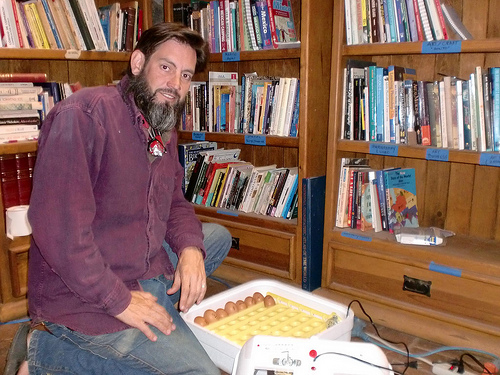<image>
Is the book on the shelf? Yes. Looking at the image, I can see the book is positioned on top of the shelf, with the shelf providing support. Is there a book on the man? No. The book is not positioned on the man. They may be near each other, but the book is not supported by or resting on top of the man. Where is the man in relation to the box? Is it on the box? No. The man is not positioned on the box. They may be near each other, but the man is not supported by or resting on top of the box. Where is the cupboard in relation to the man? Is it in front of the man? No. The cupboard is not in front of the man. The spatial positioning shows a different relationship between these objects. 